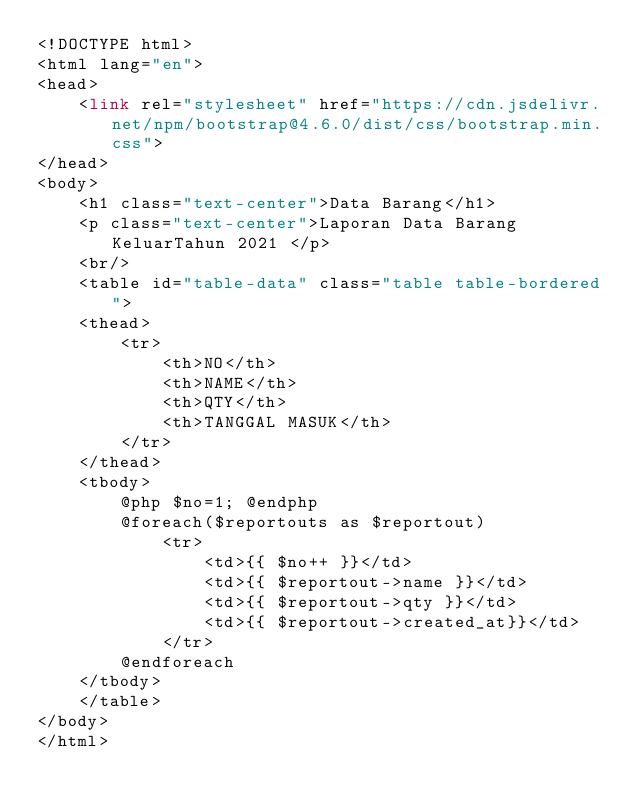Convert code to text. <code><loc_0><loc_0><loc_500><loc_500><_PHP_><!DOCTYPE html>
<html lang="en">
<head>
    <link rel="stylesheet" href="https://cdn.jsdelivr.net/npm/bootstrap@4.6.0/dist/css/bootstrap.min.css">
</head>
<body>
    <h1 class="text-center">Data Barang</h1>
    <p class="text-center">Laporan Data Barang KeluarTahun 2021 </p>
    <br/>
    <table id="table-data" class="table table-bordered">
    <thead>
        <tr>
            <th>NO</th>
            <th>NAME</th>
            <th>QTY</th>
            <th>TANGGAL MASUK</th>
        </tr>
    </thead>
    <tbody>
        @php $no=1; @endphp
        @foreach($reportouts as $reportout)
            <tr>
                <td>{{ $no++ }}</td>
                <td>{{ $reportout->name }}</td>
                <td>{{ $reportout->qty }}</td>
                <td>{{ $reportout->created_at}}</td>
            </tr>
        @endforeach
    </tbody>
    </table>
</body>
</html></code> 